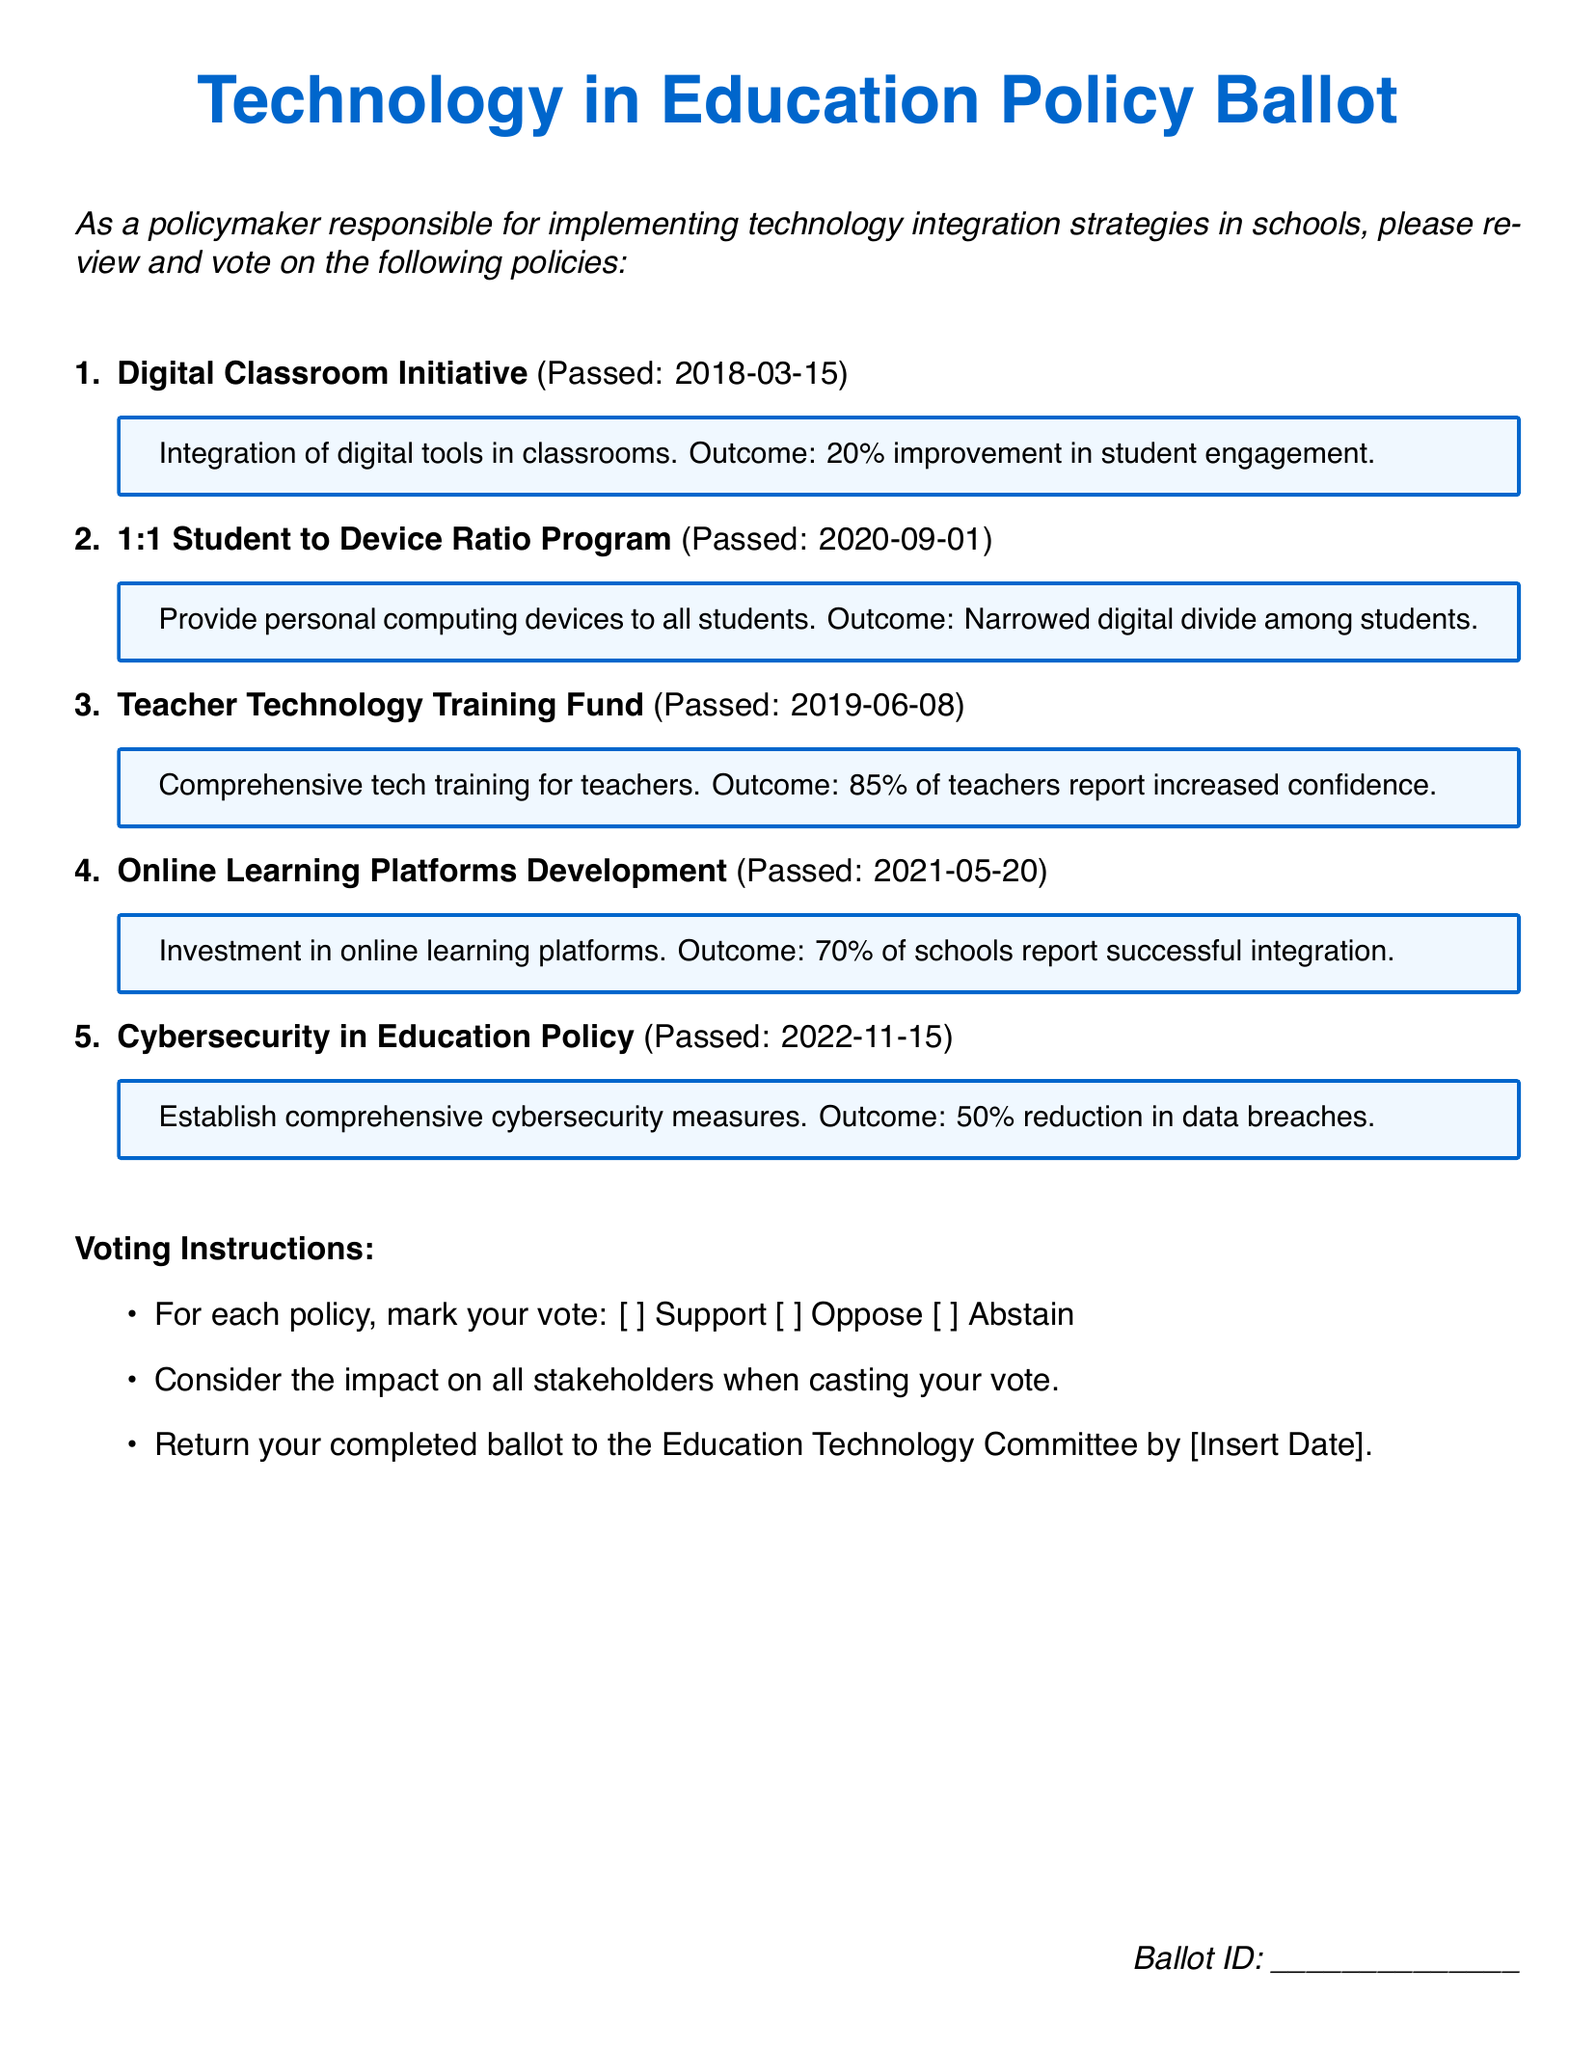What is the title of the first policy? The title of the first policy is listed at the beginning of the respective section.
Answer: Digital Classroom Initiative What is the outcome of the 1:1 Student to Device Ratio Program? The outcome is described in a bullet point following the policy details.
Answer: Narrowed digital divide among students When was the Teacher Technology Training Fund passed? The date of passage is included in parentheses next to the policy title.
Answer: 2019-06-08 What percentage of teachers reported increased confidence after the training? The percentage is stated in the outcome section of the respective policy.
Answer: 85% What is the voting instruction for each policy? The specific instruction is provided in the voting instructions section.
Answer: Mark your vote: Support, Oppose, Abstain What reduced by 50% according to the Cybersecurity in Education Policy? The result of implementing the policy is mentioned in the outcome part of the policy description.
Answer: Data breaches Which policy was passed most recently? The latest date found among the policies indicates which one is the most recent.
Answer: Cybersecurity in Education Policy What does the Digital Classroom Initiative aim to improve? The goal of the initiative is summarized in the outcome description.
Answer: Student engagement What color is used for the background of the policy box? The color of the policy box background is noted in the document.
Answer: Light blue (boxcolor) 